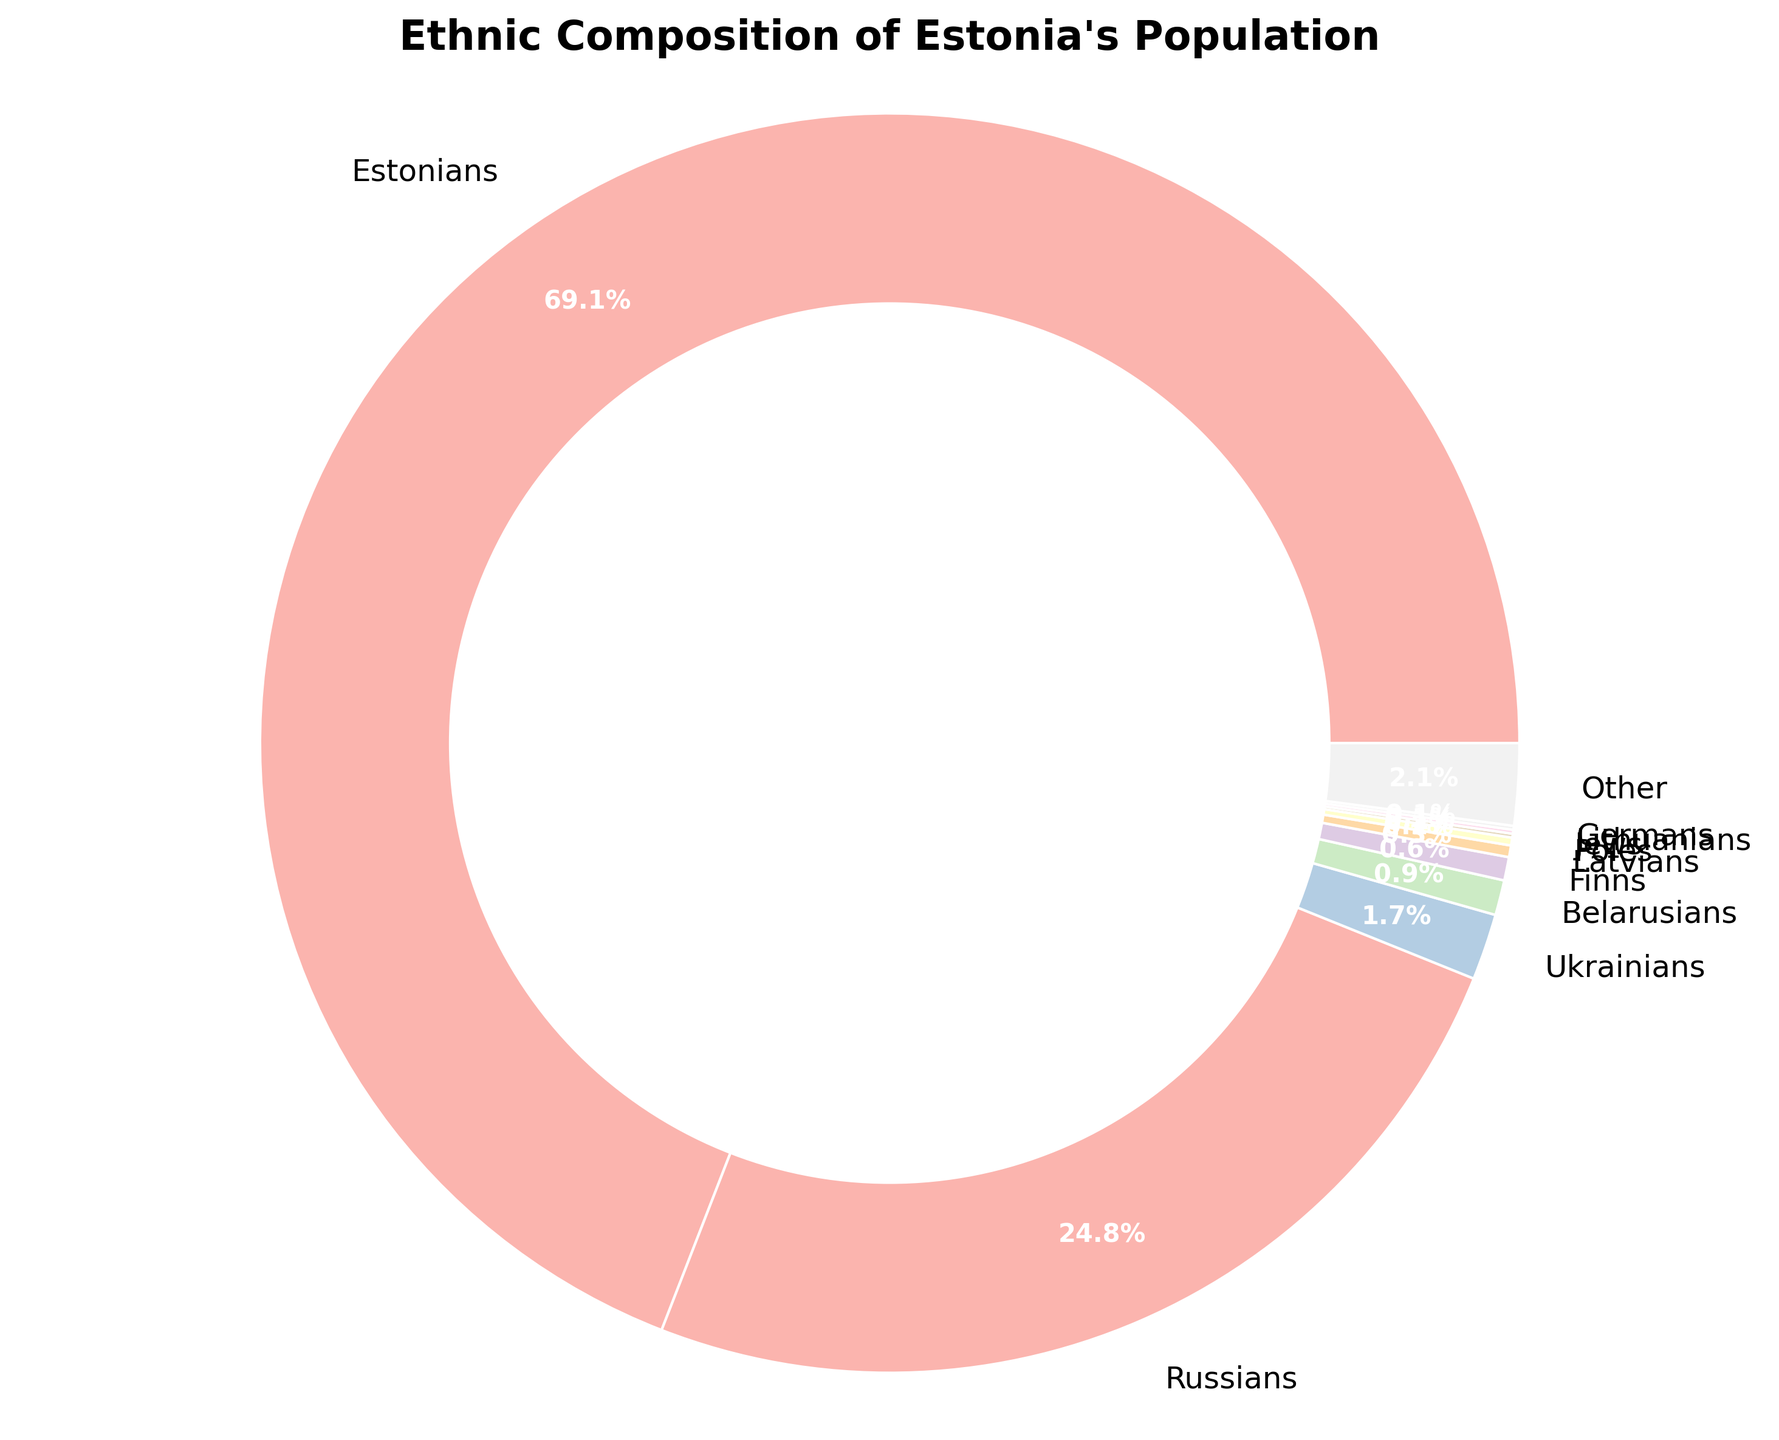What's the combined percentage of Ukrainians, Belarusians, and Finns? First, identify the percentage for each ethnicity: Ukrainians (1.7%), Belarusians (0.9%), and Finns (0.6%). Then, add these percentages together: 1.7 + 0.9 + 0.6 = 3.2.
Answer: 3.2% Which group has the second highest percentage after Estonians? The chart shows the percentages of each ethnic group. After Estonians (69.1%), the next highest percentage is for Russians at 24.8%.
Answer: Russians How much larger is the percentage of Belarusians compared to Poles? First, identify the percentages: Belarusians (0.9%) and Poles (0.2%). Subtract the percentage of Poles from Belarusians: 0.9 - 0.2 = 0.7.
Answer: 0.7% What percentage of the population do the ethnic groups with less than 1% each collectively make up? Identify the groups with less than 1%: Ukrainians (1.7% excluded as it's >1%), Belarusians (0.9%), Finns (0.6%), Latvians (0.3%), Poles (0.2%), Jews (0.1%), Lithuanians (0.1%), Germans (0.1%). Sum these percentages: 0.9 + 0.6 + 0.3 + 0.2 + 0.1 + 0.1 + 0.1 = 2.3.
Answer: 2.3% Which ethnicity is represented by the smallest wedge in the pie chart? The chart shows percentages of each ethnicity, and the smallest percentage listed is 0.1%, which is shared by Jews, Lithuanians, and Germans.
Answer: Jews, Lithuanians, Germans Is the percentage of Russians more than three times the percentage of Ukrainians? First, find three times the percentage of Ukrainians: 1.7 * 3 = 5.1. Compare this number with the percentage of Russians (24.8%). Since 24.8 is greater than 5.1, the statement is true.
Answer: Yes How does the "Other" category compare to the Finns in terms of percentage size? Identify the percentages: Other (2.1%) and Finns (0.6%). Compare the two values: 2.1 is significantly larger than 0.6.
Answer: The "Other" category is larger What is the difference between the percentage of Russians and the total percentage of all groups with less than 1%? Identify the percentage of Russians (24.8%) and sum all groups with less than 1% (Belarusians 0.9%, Finns 0.6%, Latvians 0.3%, Poles 0.2%, Jews 0.1%, Lithuanians 0.1%, Germans 0.1%). The total is 2.3%. Subtract this from 24.8%: 24.8 - 2.3 = 22.5.
Answer: 22.5% What's the percentage difference between Estonians and all other ethnic groups combined? First, find the percentage of all other ethnic groups combined: sum up all percentages excluding Estonians: 24.8 + 1.7 + 0.9 + 0.6 + 0.3 + 0.2 + 0.1 + 0.1 + 0.1 + 2.1 = 30.9%. Subtract this from Estonians' percentage: 69.1 - 30.9 = 38.2.
Answer: 38.2% What’s the second smallest group by percentage? The chart shows the ethnic groups and percentages. The smallest groups are Jews, Lithuanians, and Germans each at 0.1%. The next smallest percentage is for Poles at 0.2%.
Answer: Poles 